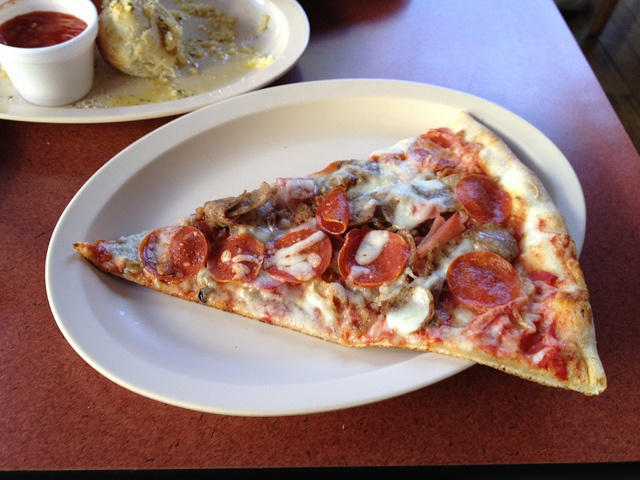Describe the objects in this image and their specific colors. I can see dining table in darkgray, maroon, lavender, and black tones, pizza in darkgray, brown, and maroon tones, and bowl in darkgray, white, maroon, and gray tones in this image. 